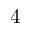<formula> <loc_0><loc_0><loc_500><loc_500>4</formula> 